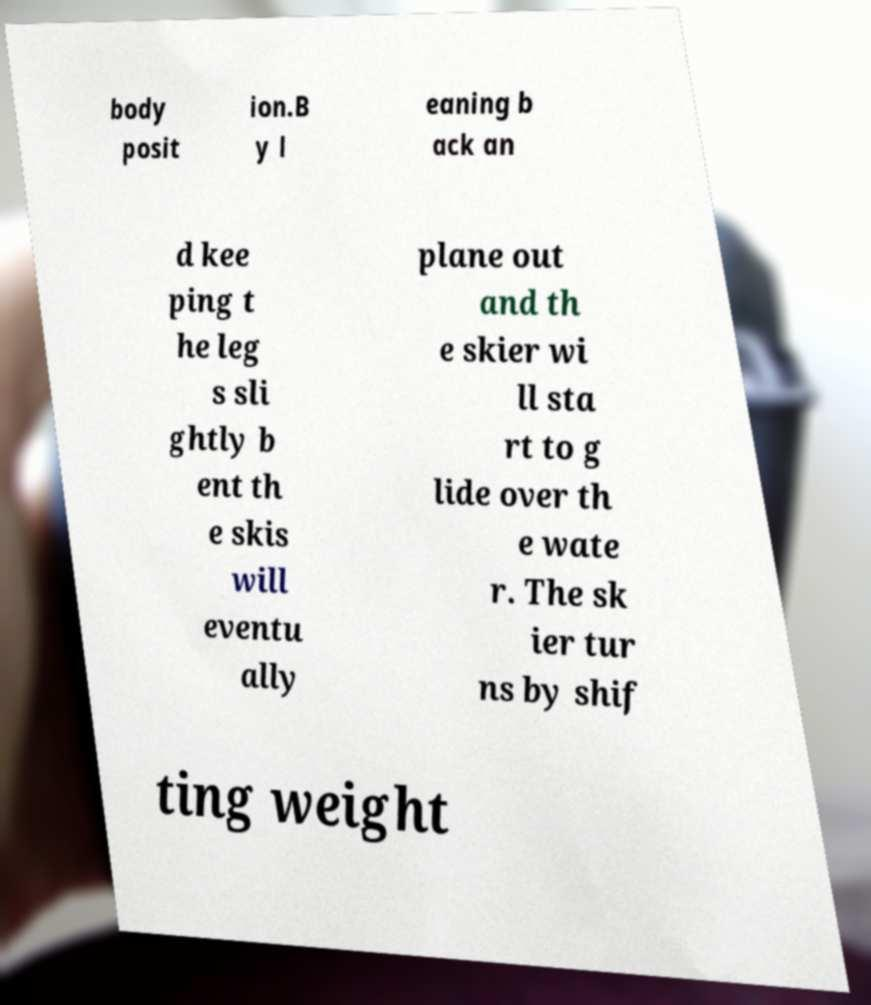Could you assist in decoding the text presented in this image and type it out clearly? body posit ion.B y l eaning b ack an d kee ping t he leg s sli ghtly b ent th e skis will eventu ally plane out and th e skier wi ll sta rt to g lide over th e wate r. The sk ier tur ns by shif ting weight 